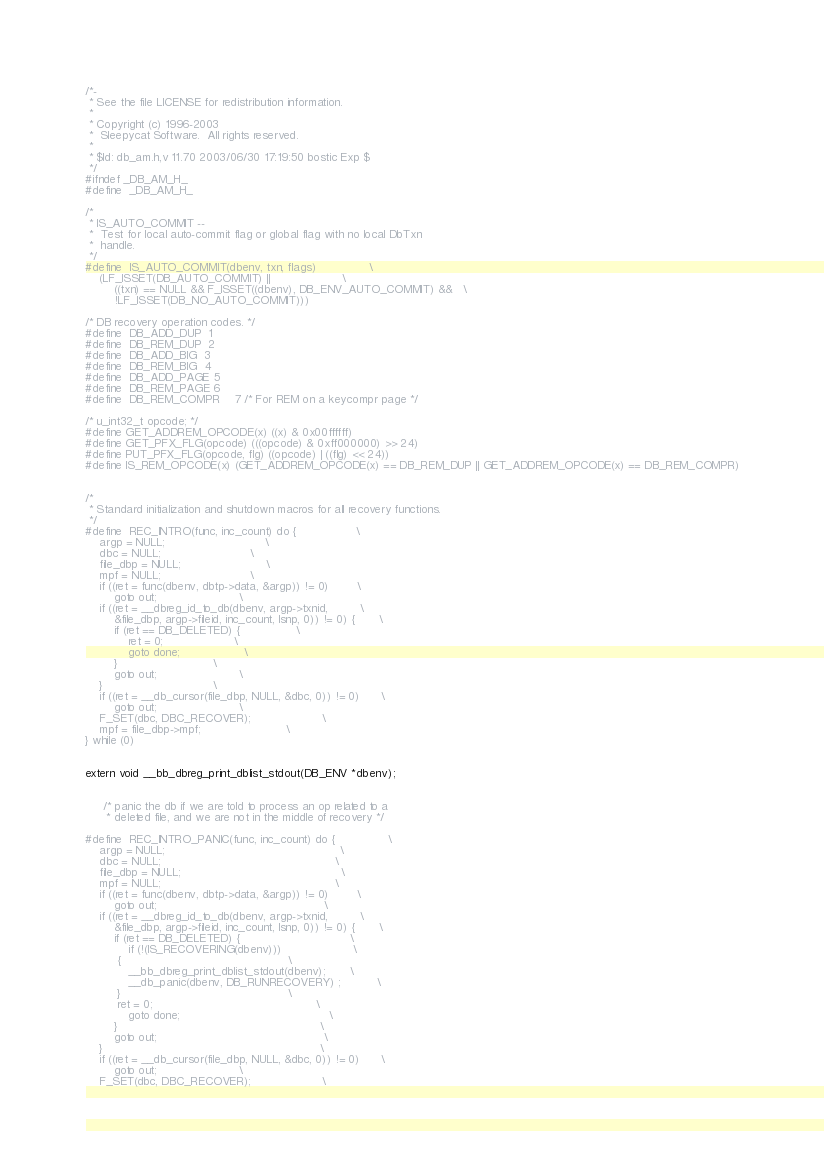Convert code to text. <code><loc_0><loc_0><loc_500><loc_500><_C_>/*-
 * See the file LICENSE for redistribution information.
 *
 * Copyright (c) 1996-2003
 *	Sleepycat Software.  All rights reserved.
 *
 * $Id: db_am.h,v 11.70 2003/06/30 17:19:50 bostic Exp $
 */
#ifndef _DB_AM_H_
#define	_DB_AM_H_

/*
 * IS_AUTO_COMMIT --
 *	Test for local auto-commit flag or global flag with no local DbTxn
 *	handle.
 */
#define	IS_AUTO_COMMIT(dbenv, txn, flags)				\
	(LF_ISSET(DB_AUTO_COMMIT) ||					\
	    ((txn) == NULL && F_ISSET((dbenv), DB_ENV_AUTO_COMMIT) &&	\
	    !LF_ISSET(DB_NO_AUTO_COMMIT)))

/* DB recovery operation codes. */
#define	DB_ADD_DUP	1
#define	DB_REM_DUP	2
#define	DB_ADD_BIG	3
#define	DB_REM_BIG	4
#define	DB_ADD_PAGE	5
#define	DB_REM_PAGE	6
#define	DB_REM_COMPR	7 /* For REM on a keycompr page */

/* u_int32_t opcode; */
#define GET_ADDREM_OPCODE(x) ((x) & 0x00ffffff)
#define GET_PFX_FLG(opcode) (((opcode) & 0xff000000) >> 24)
#define PUT_PFX_FLG(opcode, flg) ((opcode) | ((flg) << 24))
#define IS_REM_OPCODE(x) (GET_ADDREM_OPCODE(x) == DB_REM_DUP || GET_ADDREM_OPCODE(x) == DB_REM_COMPR)


/*
 * Standard initialization and shutdown macros for all recovery functions.
 */
#define	REC_INTRO(func, inc_count) do {					\
	argp = NULL;							\
	dbc = NULL;							\
	file_dbp = NULL;						\
	mpf = NULL;							\
	if ((ret = func(dbenv, dbtp->data, &argp)) != 0)		\
		goto out;						\
	if ((ret = __dbreg_id_to_db(dbenv, argp->txnid,			\
	    &file_dbp, argp->fileid, inc_count, lsnp, 0)) != 0) { 		\
		if (ret	== DB_DELETED) {				\
			ret = 0;					\
			goto done;					\
		}							\
		goto out;						\
	}								\
	if ((ret = __db_cursor(file_dbp, NULL, &dbc, 0)) != 0)		\
		goto out;						\
	F_SET(dbc, DBC_RECOVER);					\
	mpf = file_dbp->mpf;						\
} while (0)


extern void __bb_dbreg_print_dblist_stdout(DB_ENV *dbenv);


     /* panic the db if we are told to process an op related to a
      * deleted file, and we are not in the middle of recovery */

#define	REC_INTRO_PANIC(func, inc_count) do {				\
	argp = NULL;							                     \
	dbc = NULL;							                        \
	file_dbp = NULL;						                     \
	mpf = NULL;							                        \
	if ((ret = func(dbenv, dbtp->data, &argp)) != 0)		\
		goto out;						                        \
	if ((ret = __dbreg_id_to_db(dbenv, argp->txnid,			\
	    &file_dbp, argp->fileid, inc_count, lsnp, 0)) != 0) {		\
		if (ret	== DB_DELETED) {				               \
			if (!(IS_RECOVERING(dbenv)))                    \
         {                                               \
            __bb_dbreg_print_dblist_stdout(dbenv);       \
            __db_panic(dbenv, DB_RUNRECOVERY) ;          \
         }                                               \
         ret = 0;					                           \
			goto done;					                        \
		}							                              \
		goto out;						                        \
	}								                              \
	if ((ret = __db_cursor(file_dbp, NULL, &dbc, 0)) != 0)		\
		goto out;						\
	F_SET(dbc, DBC_RECOVER);					\</code> 